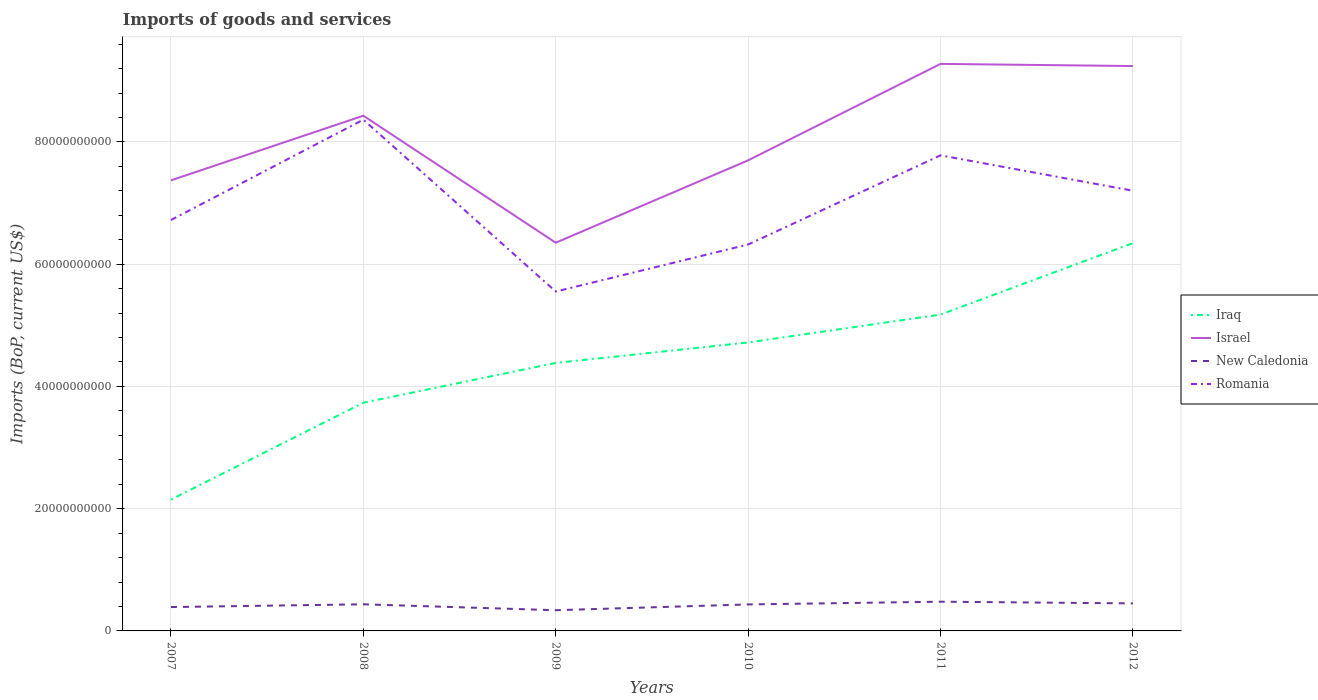Across all years, what is the maximum amount spent on imports in New Caledonia?
Your response must be concise. 3.39e+09. In which year was the amount spent on imports in Israel maximum?
Ensure brevity in your answer.  2009. What is the total amount spent on imports in Israel in the graph?
Give a very brief answer. -2.93e+1. What is the difference between the highest and the second highest amount spent on imports in Iraq?
Ensure brevity in your answer.  4.20e+1. Is the amount spent on imports in New Caledonia strictly greater than the amount spent on imports in Romania over the years?
Keep it short and to the point. Yes. How many lines are there?
Give a very brief answer. 4. How many years are there in the graph?
Offer a very short reply. 6. What is the difference between two consecutive major ticks on the Y-axis?
Provide a short and direct response. 2.00e+1. Does the graph contain any zero values?
Offer a very short reply. No. Does the graph contain grids?
Make the answer very short. Yes. How are the legend labels stacked?
Provide a short and direct response. Vertical. What is the title of the graph?
Provide a short and direct response. Imports of goods and services. Does "Libya" appear as one of the legend labels in the graph?
Keep it short and to the point. No. What is the label or title of the Y-axis?
Make the answer very short. Imports (BoP, current US$). What is the Imports (BoP, current US$) of Iraq in 2007?
Your answer should be very brief. 2.15e+1. What is the Imports (BoP, current US$) of Israel in 2007?
Your response must be concise. 7.37e+1. What is the Imports (BoP, current US$) in New Caledonia in 2007?
Provide a succinct answer. 3.90e+09. What is the Imports (BoP, current US$) of Romania in 2007?
Ensure brevity in your answer.  6.72e+1. What is the Imports (BoP, current US$) in Iraq in 2008?
Your answer should be very brief. 3.73e+1. What is the Imports (BoP, current US$) in Israel in 2008?
Offer a very short reply. 8.43e+1. What is the Imports (BoP, current US$) of New Caledonia in 2008?
Your response must be concise. 4.35e+09. What is the Imports (BoP, current US$) of Romania in 2008?
Your response must be concise. 8.36e+1. What is the Imports (BoP, current US$) in Iraq in 2009?
Make the answer very short. 4.38e+1. What is the Imports (BoP, current US$) of Israel in 2009?
Your answer should be very brief. 6.35e+1. What is the Imports (BoP, current US$) of New Caledonia in 2009?
Give a very brief answer. 3.39e+09. What is the Imports (BoP, current US$) in Romania in 2009?
Give a very brief answer. 5.55e+1. What is the Imports (BoP, current US$) in Iraq in 2010?
Your answer should be very brief. 4.72e+1. What is the Imports (BoP, current US$) of Israel in 2010?
Give a very brief answer. 7.70e+1. What is the Imports (BoP, current US$) in New Caledonia in 2010?
Provide a short and direct response. 4.33e+09. What is the Imports (BoP, current US$) in Romania in 2010?
Your answer should be compact. 6.32e+1. What is the Imports (BoP, current US$) of Iraq in 2011?
Your answer should be very brief. 5.18e+1. What is the Imports (BoP, current US$) in Israel in 2011?
Make the answer very short. 9.28e+1. What is the Imports (BoP, current US$) of New Caledonia in 2011?
Give a very brief answer. 4.78e+09. What is the Imports (BoP, current US$) in Romania in 2011?
Provide a short and direct response. 7.78e+1. What is the Imports (BoP, current US$) of Iraq in 2012?
Offer a terse response. 6.34e+1. What is the Imports (BoP, current US$) of Israel in 2012?
Give a very brief answer. 9.24e+1. What is the Imports (BoP, current US$) in New Caledonia in 2012?
Offer a terse response. 4.50e+09. What is the Imports (BoP, current US$) of Romania in 2012?
Ensure brevity in your answer.  7.20e+1. Across all years, what is the maximum Imports (BoP, current US$) in Iraq?
Offer a terse response. 6.34e+1. Across all years, what is the maximum Imports (BoP, current US$) of Israel?
Provide a succinct answer. 9.28e+1. Across all years, what is the maximum Imports (BoP, current US$) of New Caledonia?
Your response must be concise. 4.78e+09. Across all years, what is the maximum Imports (BoP, current US$) in Romania?
Ensure brevity in your answer.  8.36e+1. Across all years, what is the minimum Imports (BoP, current US$) in Iraq?
Provide a short and direct response. 2.15e+1. Across all years, what is the minimum Imports (BoP, current US$) in Israel?
Make the answer very short. 6.35e+1. Across all years, what is the minimum Imports (BoP, current US$) of New Caledonia?
Offer a terse response. 3.39e+09. Across all years, what is the minimum Imports (BoP, current US$) in Romania?
Offer a terse response. 5.55e+1. What is the total Imports (BoP, current US$) in Iraq in the graph?
Ensure brevity in your answer.  2.65e+11. What is the total Imports (BoP, current US$) of Israel in the graph?
Provide a succinct answer. 4.84e+11. What is the total Imports (BoP, current US$) in New Caledonia in the graph?
Give a very brief answer. 2.53e+1. What is the total Imports (BoP, current US$) in Romania in the graph?
Provide a short and direct response. 4.19e+11. What is the difference between the Imports (BoP, current US$) of Iraq in 2007 and that in 2008?
Give a very brief answer. -1.58e+1. What is the difference between the Imports (BoP, current US$) of Israel in 2007 and that in 2008?
Ensure brevity in your answer.  -1.06e+1. What is the difference between the Imports (BoP, current US$) in New Caledonia in 2007 and that in 2008?
Offer a very short reply. -4.51e+08. What is the difference between the Imports (BoP, current US$) of Romania in 2007 and that in 2008?
Provide a short and direct response. -1.64e+1. What is the difference between the Imports (BoP, current US$) of Iraq in 2007 and that in 2009?
Ensure brevity in your answer.  -2.24e+1. What is the difference between the Imports (BoP, current US$) of Israel in 2007 and that in 2009?
Give a very brief answer. 1.02e+1. What is the difference between the Imports (BoP, current US$) in New Caledonia in 2007 and that in 2009?
Provide a succinct answer. 5.16e+08. What is the difference between the Imports (BoP, current US$) in Romania in 2007 and that in 2009?
Offer a very short reply. 1.17e+1. What is the difference between the Imports (BoP, current US$) of Iraq in 2007 and that in 2010?
Make the answer very short. -2.57e+1. What is the difference between the Imports (BoP, current US$) of Israel in 2007 and that in 2010?
Give a very brief answer. -3.27e+09. What is the difference between the Imports (BoP, current US$) in New Caledonia in 2007 and that in 2010?
Make the answer very short. -4.29e+08. What is the difference between the Imports (BoP, current US$) of Romania in 2007 and that in 2010?
Ensure brevity in your answer.  4.01e+09. What is the difference between the Imports (BoP, current US$) in Iraq in 2007 and that in 2011?
Make the answer very short. -3.03e+1. What is the difference between the Imports (BoP, current US$) of Israel in 2007 and that in 2011?
Offer a terse response. -1.91e+1. What is the difference between the Imports (BoP, current US$) of New Caledonia in 2007 and that in 2011?
Give a very brief answer. -8.78e+08. What is the difference between the Imports (BoP, current US$) of Romania in 2007 and that in 2011?
Your answer should be very brief. -1.06e+1. What is the difference between the Imports (BoP, current US$) in Iraq in 2007 and that in 2012?
Your response must be concise. -4.20e+1. What is the difference between the Imports (BoP, current US$) in Israel in 2007 and that in 2012?
Offer a terse response. -1.87e+1. What is the difference between the Imports (BoP, current US$) of New Caledonia in 2007 and that in 2012?
Ensure brevity in your answer.  -6.01e+08. What is the difference between the Imports (BoP, current US$) in Romania in 2007 and that in 2012?
Your answer should be compact. -4.79e+09. What is the difference between the Imports (BoP, current US$) of Iraq in 2008 and that in 2009?
Your answer should be very brief. -6.51e+09. What is the difference between the Imports (BoP, current US$) of Israel in 2008 and that in 2009?
Offer a very short reply. 2.08e+1. What is the difference between the Imports (BoP, current US$) of New Caledonia in 2008 and that in 2009?
Offer a very short reply. 9.67e+08. What is the difference between the Imports (BoP, current US$) in Romania in 2008 and that in 2009?
Provide a short and direct response. 2.81e+1. What is the difference between the Imports (BoP, current US$) in Iraq in 2008 and that in 2010?
Your answer should be very brief. -9.86e+09. What is the difference between the Imports (BoP, current US$) of Israel in 2008 and that in 2010?
Ensure brevity in your answer.  7.30e+09. What is the difference between the Imports (BoP, current US$) of New Caledonia in 2008 and that in 2010?
Offer a terse response. 2.13e+07. What is the difference between the Imports (BoP, current US$) of Romania in 2008 and that in 2010?
Offer a very short reply. 2.04e+1. What is the difference between the Imports (BoP, current US$) of Iraq in 2008 and that in 2011?
Offer a very short reply. -1.44e+1. What is the difference between the Imports (BoP, current US$) in Israel in 2008 and that in 2011?
Keep it short and to the point. -8.48e+09. What is the difference between the Imports (BoP, current US$) in New Caledonia in 2008 and that in 2011?
Make the answer very short. -4.27e+08. What is the difference between the Imports (BoP, current US$) of Romania in 2008 and that in 2011?
Ensure brevity in your answer.  5.84e+09. What is the difference between the Imports (BoP, current US$) of Iraq in 2008 and that in 2012?
Make the answer very short. -2.61e+1. What is the difference between the Imports (BoP, current US$) in Israel in 2008 and that in 2012?
Your answer should be very brief. -8.13e+09. What is the difference between the Imports (BoP, current US$) in New Caledonia in 2008 and that in 2012?
Keep it short and to the point. -1.50e+08. What is the difference between the Imports (BoP, current US$) of Romania in 2008 and that in 2012?
Offer a terse response. 1.16e+1. What is the difference between the Imports (BoP, current US$) in Iraq in 2009 and that in 2010?
Give a very brief answer. -3.34e+09. What is the difference between the Imports (BoP, current US$) of Israel in 2009 and that in 2010?
Provide a short and direct response. -1.35e+1. What is the difference between the Imports (BoP, current US$) of New Caledonia in 2009 and that in 2010?
Your response must be concise. -9.46e+08. What is the difference between the Imports (BoP, current US$) in Romania in 2009 and that in 2010?
Provide a short and direct response. -7.69e+09. What is the difference between the Imports (BoP, current US$) of Iraq in 2009 and that in 2011?
Your answer should be very brief. -7.91e+09. What is the difference between the Imports (BoP, current US$) of Israel in 2009 and that in 2011?
Your response must be concise. -2.93e+1. What is the difference between the Imports (BoP, current US$) in New Caledonia in 2009 and that in 2011?
Keep it short and to the point. -1.39e+09. What is the difference between the Imports (BoP, current US$) of Romania in 2009 and that in 2011?
Your answer should be very brief. -2.23e+1. What is the difference between the Imports (BoP, current US$) of Iraq in 2009 and that in 2012?
Your answer should be compact. -1.96e+1. What is the difference between the Imports (BoP, current US$) in Israel in 2009 and that in 2012?
Your answer should be very brief. -2.89e+1. What is the difference between the Imports (BoP, current US$) of New Caledonia in 2009 and that in 2012?
Keep it short and to the point. -1.12e+09. What is the difference between the Imports (BoP, current US$) of Romania in 2009 and that in 2012?
Keep it short and to the point. -1.65e+1. What is the difference between the Imports (BoP, current US$) in Iraq in 2010 and that in 2011?
Your answer should be compact. -4.57e+09. What is the difference between the Imports (BoP, current US$) in Israel in 2010 and that in 2011?
Offer a very short reply. -1.58e+1. What is the difference between the Imports (BoP, current US$) in New Caledonia in 2010 and that in 2011?
Provide a short and direct response. -4.48e+08. What is the difference between the Imports (BoP, current US$) in Romania in 2010 and that in 2011?
Your answer should be very brief. -1.46e+1. What is the difference between the Imports (BoP, current US$) of Iraq in 2010 and that in 2012?
Your response must be concise. -1.63e+1. What is the difference between the Imports (BoP, current US$) in Israel in 2010 and that in 2012?
Provide a short and direct response. -1.54e+1. What is the difference between the Imports (BoP, current US$) of New Caledonia in 2010 and that in 2012?
Your answer should be very brief. -1.71e+08. What is the difference between the Imports (BoP, current US$) of Romania in 2010 and that in 2012?
Provide a succinct answer. -8.80e+09. What is the difference between the Imports (BoP, current US$) in Iraq in 2011 and that in 2012?
Keep it short and to the point. -1.17e+1. What is the difference between the Imports (BoP, current US$) of Israel in 2011 and that in 2012?
Your response must be concise. 3.53e+08. What is the difference between the Imports (BoP, current US$) in New Caledonia in 2011 and that in 2012?
Keep it short and to the point. 2.77e+08. What is the difference between the Imports (BoP, current US$) of Romania in 2011 and that in 2012?
Give a very brief answer. 5.79e+09. What is the difference between the Imports (BoP, current US$) in Iraq in 2007 and the Imports (BoP, current US$) in Israel in 2008?
Provide a short and direct response. -6.28e+1. What is the difference between the Imports (BoP, current US$) of Iraq in 2007 and the Imports (BoP, current US$) of New Caledonia in 2008?
Offer a very short reply. 1.71e+1. What is the difference between the Imports (BoP, current US$) of Iraq in 2007 and the Imports (BoP, current US$) of Romania in 2008?
Offer a terse response. -6.22e+1. What is the difference between the Imports (BoP, current US$) of Israel in 2007 and the Imports (BoP, current US$) of New Caledonia in 2008?
Your answer should be compact. 6.94e+1. What is the difference between the Imports (BoP, current US$) of Israel in 2007 and the Imports (BoP, current US$) of Romania in 2008?
Make the answer very short. -9.93e+09. What is the difference between the Imports (BoP, current US$) in New Caledonia in 2007 and the Imports (BoP, current US$) in Romania in 2008?
Ensure brevity in your answer.  -7.97e+1. What is the difference between the Imports (BoP, current US$) in Iraq in 2007 and the Imports (BoP, current US$) in Israel in 2009?
Make the answer very short. -4.20e+1. What is the difference between the Imports (BoP, current US$) in Iraq in 2007 and the Imports (BoP, current US$) in New Caledonia in 2009?
Your response must be concise. 1.81e+1. What is the difference between the Imports (BoP, current US$) of Iraq in 2007 and the Imports (BoP, current US$) of Romania in 2009?
Your answer should be very brief. -3.40e+1. What is the difference between the Imports (BoP, current US$) in Israel in 2007 and the Imports (BoP, current US$) in New Caledonia in 2009?
Provide a succinct answer. 7.03e+1. What is the difference between the Imports (BoP, current US$) of Israel in 2007 and the Imports (BoP, current US$) of Romania in 2009?
Your answer should be compact. 1.82e+1. What is the difference between the Imports (BoP, current US$) in New Caledonia in 2007 and the Imports (BoP, current US$) in Romania in 2009?
Your answer should be compact. -5.16e+1. What is the difference between the Imports (BoP, current US$) in Iraq in 2007 and the Imports (BoP, current US$) in Israel in 2010?
Provide a succinct answer. -5.55e+1. What is the difference between the Imports (BoP, current US$) in Iraq in 2007 and the Imports (BoP, current US$) in New Caledonia in 2010?
Your response must be concise. 1.72e+1. What is the difference between the Imports (BoP, current US$) in Iraq in 2007 and the Imports (BoP, current US$) in Romania in 2010?
Provide a succinct answer. -4.17e+1. What is the difference between the Imports (BoP, current US$) in Israel in 2007 and the Imports (BoP, current US$) in New Caledonia in 2010?
Your answer should be very brief. 6.94e+1. What is the difference between the Imports (BoP, current US$) in Israel in 2007 and the Imports (BoP, current US$) in Romania in 2010?
Keep it short and to the point. 1.05e+1. What is the difference between the Imports (BoP, current US$) in New Caledonia in 2007 and the Imports (BoP, current US$) in Romania in 2010?
Ensure brevity in your answer.  -5.93e+1. What is the difference between the Imports (BoP, current US$) in Iraq in 2007 and the Imports (BoP, current US$) in Israel in 2011?
Give a very brief answer. -7.13e+1. What is the difference between the Imports (BoP, current US$) in Iraq in 2007 and the Imports (BoP, current US$) in New Caledonia in 2011?
Keep it short and to the point. 1.67e+1. What is the difference between the Imports (BoP, current US$) of Iraq in 2007 and the Imports (BoP, current US$) of Romania in 2011?
Provide a short and direct response. -5.63e+1. What is the difference between the Imports (BoP, current US$) of Israel in 2007 and the Imports (BoP, current US$) of New Caledonia in 2011?
Your response must be concise. 6.89e+1. What is the difference between the Imports (BoP, current US$) in Israel in 2007 and the Imports (BoP, current US$) in Romania in 2011?
Provide a succinct answer. -4.09e+09. What is the difference between the Imports (BoP, current US$) in New Caledonia in 2007 and the Imports (BoP, current US$) in Romania in 2011?
Offer a very short reply. -7.39e+1. What is the difference between the Imports (BoP, current US$) in Iraq in 2007 and the Imports (BoP, current US$) in Israel in 2012?
Provide a succinct answer. -7.09e+1. What is the difference between the Imports (BoP, current US$) of Iraq in 2007 and the Imports (BoP, current US$) of New Caledonia in 2012?
Offer a terse response. 1.70e+1. What is the difference between the Imports (BoP, current US$) in Iraq in 2007 and the Imports (BoP, current US$) in Romania in 2012?
Provide a succinct answer. -5.05e+1. What is the difference between the Imports (BoP, current US$) of Israel in 2007 and the Imports (BoP, current US$) of New Caledonia in 2012?
Give a very brief answer. 6.92e+1. What is the difference between the Imports (BoP, current US$) of Israel in 2007 and the Imports (BoP, current US$) of Romania in 2012?
Offer a very short reply. 1.70e+09. What is the difference between the Imports (BoP, current US$) in New Caledonia in 2007 and the Imports (BoP, current US$) in Romania in 2012?
Provide a short and direct response. -6.81e+1. What is the difference between the Imports (BoP, current US$) in Iraq in 2008 and the Imports (BoP, current US$) in Israel in 2009?
Make the answer very short. -2.62e+1. What is the difference between the Imports (BoP, current US$) of Iraq in 2008 and the Imports (BoP, current US$) of New Caledonia in 2009?
Your answer should be very brief. 3.39e+1. What is the difference between the Imports (BoP, current US$) of Iraq in 2008 and the Imports (BoP, current US$) of Romania in 2009?
Provide a short and direct response. -1.82e+1. What is the difference between the Imports (BoP, current US$) of Israel in 2008 and the Imports (BoP, current US$) of New Caledonia in 2009?
Your answer should be compact. 8.09e+1. What is the difference between the Imports (BoP, current US$) in Israel in 2008 and the Imports (BoP, current US$) in Romania in 2009?
Keep it short and to the point. 2.88e+1. What is the difference between the Imports (BoP, current US$) of New Caledonia in 2008 and the Imports (BoP, current US$) of Romania in 2009?
Your answer should be compact. -5.12e+1. What is the difference between the Imports (BoP, current US$) in Iraq in 2008 and the Imports (BoP, current US$) in Israel in 2010?
Give a very brief answer. -3.97e+1. What is the difference between the Imports (BoP, current US$) of Iraq in 2008 and the Imports (BoP, current US$) of New Caledonia in 2010?
Keep it short and to the point. 3.30e+1. What is the difference between the Imports (BoP, current US$) of Iraq in 2008 and the Imports (BoP, current US$) of Romania in 2010?
Ensure brevity in your answer.  -2.59e+1. What is the difference between the Imports (BoP, current US$) of Israel in 2008 and the Imports (BoP, current US$) of New Caledonia in 2010?
Provide a succinct answer. 8.00e+1. What is the difference between the Imports (BoP, current US$) in Israel in 2008 and the Imports (BoP, current US$) in Romania in 2010?
Your answer should be compact. 2.11e+1. What is the difference between the Imports (BoP, current US$) in New Caledonia in 2008 and the Imports (BoP, current US$) in Romania in 2010?
Provide a short and direct response. -5.89e+1. What is the difference between the Imports (BoP, current US$) in Iraq in 2008 and the Imports (BoP, current US$) in Israel in 2011?
Provide a short and direct response. -5.54e+1. What is the difference between the Imports (BoP, current US$) of Iraq in 2008 and the Imports (BoP, current US$) of New Caledonia in 2011?
Your answer should be very brief. 3.26e+1. What is the difference between the Imports (BoP, current US$) in Iraq in 2008 and the Imports (BoP, current US$) in Romania in 2011?
Provide a short and direct response. -4.05e+1. What is the difference between the Imports (BoP, current US$) of Israel in 2008 and the Imports (BoP, current US$) of New Caledonia in 2011?
Provide a succinct answer. 7.95e+1. What is the difference between the Imports (BoP, current US$) of Israel in 2008 and the Imports (BoP, current US$) of Romania in 2011?
Offer a very short reply. 6.48e+09. What is the difference between the Imports (BoP, current US$) in New Caledonia in 2008 and the Imports (BoP, current US$) in Romania in 2011?
Keep it short and to the point. -7.35e+1. What is the difference between the Imports (BoP, current US$) of Iraq in 2008 and the Imports (BoP, current US$) of Israel in 2012?
Your answer should be very brief. -5.51e+1. What is the difference between the Imports (BoP, current US$) of Iraq in 2008 and the Imports (BoP, current US$) of New Caledonia in 2012?
Your response must be concise. 3.28e+1. What is the difference between the Imports (BoP, current US$) of Iraq in 2008 and the Imports (BoP, current US$) of Romania in 2012?
Offer a terse response. -3.47e+1. What is the difference between the Imports (BoP, current US$) of Israel in 2008 and the Imports (BoP, current US$) of New Caledonia in 2012?
Keep it short and to the point. 7.98e+1. What is the difference between the Imports (BoP, current US$) in Israel in 2008 and the Imports (BoP, current US$) in Romania in 2012?
Offer a terse response. 1.23e+1. What is the difference between the Imports (BoP, current US$) in New Caledonia in 2008 and the Imports (BoP, current US$) in Romania in 2012?
Provide a short and direct response. -6.77e+1. What is the difference between the Imports (BoP, current US$) in Iraq in 2009 and the Imports (BoP, current US$) in Israel in 2010?
Provide a succinct answer. -3.31e+1. What is the difference between the Imports (BoP, current US$) in Iraq in 2009 and the Imports (BoP, current US$) in New Caledonia in 2010?
Offer a very short reply. 3.95e+1. What is the difference between the Imports (BoP, current US$) of Iraq in 2009 and the Imports (BoP, current US$) of Romania in 2010?
Provide a short and direct response. -1.94e+1. What is the difference between the Imports (BoP, current US$) of Israel in 2009 and the Imports (BoP, current US$) of New Caledonia in 2010?
Provide a short and direct response. 5.92e+1. What is the difference between the Imports (BoP, current US$) of Israel in 2009 and the Imports (BoP, current US$) of Romania in 2010?
Provide a succinct answer. 2.94e+08. What is the difference between the Imports (BoP, current US$) in New Caledonia in 2009 and the Imports (BoP, current US$) in Romania in 2010?
Your answer should be very brief. -5.98e+1. What is the difference between the Imports (BoP, current US$) of Iraq in 2009 and the Imports (BoP, current US$) of Israel in 2011?
Offer a terse response. -4.89e+1. What is the difference between the Imports (BoP, current US$) in Iraq in 2009 and the Imports (BoP, current US$) in New Caledonia in 2011?
Your answer should be very brief. 3.91e+1. What is the difference between the Imports (BoP, current US$) in Iraq in 2009 and the Imports (BoP, current US$) in Romania in 2011?
Your answer should be compact. -3.40e+1. What is the difference between the Imports (BoP, current US$) of Israel in 2009 and the Imports (BoP, current US$) of New Caledonia in 2011?
Provide a short and direct response. 5.87e+1. What is the difference between the Imports (BoP, current US$) of Israel in 2009 and the Imports (BoP, current US$) of Romania in 2011?
Keep it short and to the point. -1.43e+1. What is the difference between the Imports (BoP, current US$) of New Caledonia in 2009 and the Imports (BoP, current US$) of Romania in 2011?
Ensure brevity in your answer.  -7.44e+1. What is the difference between the Imports (BoP, current US$) in Iraq in 2009 and the Imports (BoP, current US$) in Israel in 2012?
Give a very brief answer. -4.86e+1. What is the difference between the Imports (BoP, current US$) in Iraq in 2009 and the Imports (BoP, current US$) in New Caledonia in 2012?
Ensure brevity in your answer.  3.93e+1. What is the difference between the Imports (BoP, current US$) in Iraq in 2009 and the Imports (BoP, current US$) in Romania in 2012?
Your answer should be very brief. -2.82e+1. What is the difference between the Imports (BoP, current US$) of Israel in 2009 and the Imports (BoP, current US$) of New Caledonia in 2012?
Provide a short and direct response. 5.90e+1. What is the difference between the Imports (BoP, current US$) in Israel in 2009 and the Imports (BoP, current US$) in Romania in 2012?
Offer a very short reply. -8.50e+09. What is the difference between the Imports (BoP, current US$) in New Caledonia in 2009 and the Imports (BoP, current US$) in Romania in 2012?
Your answer should be compact. -6.86e+1. What is the difference between the Imports (BoP, current US$) of Iraq in 2010 and the Imports (BoP, current US$) of Israel in 2011?
Provide a succinct answer. -4.56e+1. What is the difference between the Imports (BoP, current US$) of Iraq in 2010 and the Imports (BoP, current US$) of New Caledonia in 2011?
Ensure brevity in your answer.  4.24e+1. What is the difference between the Imports (BoP, current US$) of Iraq in 2010 and the Imports (BoP, current US$) of Romania in 2011?
Provide a succinct answer. -3.06e+1. What is the difference between the Imports (BoP, current US$) of Israel in 2010 and the Imports (BoP, current US$) of New Caledonia in 2011?
Your answer should be compact. 7.22e+1. What is the difference between the Imports (BoP, current US$) in Israel in 2010 and the Imports (BoP, current US$) in Romania in 2011?
Ensure brevity in your answer.  -8.18e+08. What is the difference between the Imports (BoP, current US$) of New Caledonia in 2010 and the Imports (BoP, current US$) of Romania in 2011?
Your response must be concise. -7.35e+1. What is the difference between the Imports (BoP, current US$) of Iraq in 2010 and the Imports (BoP, current US$) of Israel in 2012?
Ensure brevity in your answer.  -4.52e+1. What is the difference between the Imports (BoP, current US$) of Iraq in 2010 and the Imports (BoP, current US$) of New Caledonia in 2012?
Provide a succinct answer. 4.27e+1. What is the difference between the Imports (BoP, current US$) in Iraq in 2010 and the Imports (BoP, current US$) in Romania in 2012?
Ensure brevity in your answer.  -2.48e+1. What is the difference between the Imports (BoP, current US$) in Israel in 2010 and the Imports (BoP, current US$) in New Caledonia in 2012?
Ensure brevity in your answer.  7.25e+1. What is the difference between the Imports (BoP, current US$) of Israel in 2010 and the Imports (BoP, current US$) of Romania in 2012?
Offer a terse response. 4.97e+09. What is the difference between the Imports (BoP, current US$) of New Caledonia in 2010 and the Imports (BoP, current US$) of Romania in 2012?
Your answer should be very brief. -6.77e+1. What is the difference between the Imports (BoP, current US$) of Iraq in 2011 and the Imports (BoP, current US$) of Israel in 2012?
Make the answer very short. -4.07e+1. What is the difference between the Imports (BoP, current US$) of Iraq in 2011 and the Imports (BoP, current US$) of New Caledonia in 2012?
Give a very brief answer. 4.73e+1. What is the difference between the Imports (BoP, current US$) of Iraq in 2011 and the Imports (BoP, current US$) of Romania in 2012?
Keep it short and to the point. -2.03e+1. What is the difference between the Imports (BoP, current US$) of Israel in 2011 and the Imports (BoP, current US$) of New Caledonia in 2012?
Provide a short and direct response. 8.83e+1. What is the difference between the Imports (BoP, current US$) in Israel in 2011 and the Imports (BoP, current US$) in Romania in 2012?
Your response must be concise. 2.08e+1. What is the difference between the Imports (BoP, current US$) in New Caledonia in 2011 and the Imports (BoP, current US$) in Romania in 2012?
Provide a short and direct response. -6.72e+1. What is the average Imports (BoP, current US$) in Iraq per year?
Provide a succinct answer. 4.42e+1. What is the average Imports (BoP, current US$) in Israel per year?
Your response must be concise. 8.06e+1. What is the average Imports (BoP, current US$) of New Caledonia per year?
Offer a very short reply. 4.21e+09. What is the average Imports (BoP, current US$) of Romania per year?
Make the answer very short. 6.99e+1. In the year 2007, what is the difference between the Imports (BoP, current US$) in Iraq and Imports (BoP, current US$) in Israel?
Your answer should be very brief. -5.22e+1. In the year 2007, what is the difference between the Imports (BoP, current US$) in Iraq and Imports (BoP, current US$) in New Caledonia?
Your response must be concise. 1.76e+1. In the year 2007, what is the difference between the Imports (BoP, current US$) in Iraq and Imports (BoP, current US$) in Romania?
Give a very brief answer. -4.57e+1. In the year 2007, what is the difference between the Imports (BoP, current US$) of Israel and Imports (BoP, current US$) of New Caledonia?
Your response must be concise. 6.98e+1. In the year 2007, what is the difference between the Imports (BoP, current US$) in Israel and Imports (BoP, current US$) in Romania?
Provide a short and direct response. 6.49e+09. In the year 2007, what is the difference between the Imports (BoP, current US$) in New Caledonia and Imports (BoP, current US$) in Romania?
Provide a short and direct response. -6.33e+1. In the year 2008, what is the difference between the Imports (BoP, current US$) in Iraq and Imports (BoP, current US$) in Israel?
Provide a succinct answer. -4.70e+1. In the year 2008, what is the difference between the Imports (BoP, current US$) in Iraq and Imports (BoP, current US$) in New Caledonia?
Provide a short and direct response. 3.30e+1. In the year 2008, what is the difference between the Imports (BoP, current US$) in Iraq and Imports (BoP, current US$) in Romania?
Your answer should be compact. -4.63e+1. In the year 2008, what is the difference between the Imports (BoP, current US$) of Israel and Imports (BoP, current US$) of New Caledonia?
Your response must be concise. 7.99e+1. In the year 2008, what is the difference between the Imports (BoP, current US$) in Israel and Imports (BoP, current US$) in Romania?
Offer a terse response. 6.44e+08. In the year 2008, what is the difference between the Imports (BoP, current US$) of New Caledonia and Imports (BoP, current US$) of Romania?
Make the answer very short. -7.93e+1. In the year 2009, what is the difference between the Imports (BoP, current US$) of Iraq and Imports (BoP, current US$) of Israel?
Provide a succinct answer. -1.97e+1. In the year 2009, what is the difference between the Imports (BoP, current US$) of Iraq and Imports (BoP, current US$) of New Caledonia?
Offer a very short reply. 4.05e+1. In the year 2009, what is the difference between the Imports (BoP, current US$) of Iraq and Imports (BoP, current US$) of Romania?
Your answer should be compact. -1.17e+1. In the year 2009, what is the difference between the Imports (BoP, current US$) of Israel and Imports (BoP, current US$) of New Caledonia?
Keep it short and to the point. 6.01e+1. In the year 2009, what is the difference between the Imports (BoP, current US$) of Israel and Imports (BoP, current US$) of Romania?
Your response must be concise. 7.99e+09. In the year 2009, what is the difference between the Imports (BoP, current US$) in New Caledonia and Imports (BoP, current US$) in Romania?
Your answer should be compact. -5.21e+1. In the year 2010, what is the difference between the Imports (BoP, current US$) of Iraq and Imports (BoP, current US$) of Israel?
Ensure brevity in your answer.  -2.98e+1. In the year 2010, what is the difference between the Imports (BoP, current US$) of Iraq and Imports (BoP, current US$) of New Caledonia?
Give a very brief answer. 4.29e+1. In the year 2010, what is the difference between the Imports (BoP, current US$) of Iraq and Imports (BoP, current US$) of Romania?
Offer a terse response. -1.60e+1. In the year 2010, what is the difference between the Imports (BoP, current US$) of Israel and Imports (BoP, current US$) of New Caledonia?
Give a very brief answer. 7.27e+1. In the year 2010, what is the difference between the Imports (BoP, current US$) in Israel and Imports (BoP, current US$) in Romania?
Ensure brevity in your answer.  1.38e+1. In the year 2010, what is the difference between the Imports (BoP, current US$) of New Caledonia and Imports (BoP, current US$) of Romania?
Your response must be concise. -5.89e+1. In the year 2011, what is the difference between the Imports (BoP, current US$) in Iraq and Imports (BoP, current US$) in Israel?
Give a very brief answer. -4.10e+1. In the year 2011, what is the difference between the Imports (BoP, current US$) of Iraq and Imports (BoP, current US$) of New Caledonia?
Your answer should be very brief. 4.70e+1. In the year 2011, what is the difference between the Imports (BoP, current US$) of Iraq and Imports (BoP, current US$) of Romania?
Provide a succinct answer. -2.60e+1. In the year 2011, what is the difference between the Imports (BoP, current US$) in Israel and Imports (BoP, current US$) in New Caledonia?
Keep it short and to the point. 8.80e+1. In the year 2011, what is the difference between the Imports (BoP, current US$) of Israel and Imports (BoP, current US$) of Romania?
Give a very brief answer. 1.50e+1. In the year 2011, what is the difference between the Imports (BoP, current US$) of New Caledonia and Imports (BoP, current US$) of Romania?
Your answer should be compact. -7.30e+1. In the year 2012, what is the difference between the Imports (BoP, current US$) of Iraq and Imports (BoP, current US$) of Israel?
Ensure brevity in your answer.  -2.90e+1. In the year 2012, what is the difference between the Imports (BoP, current US$) in Iraq and Imports (BoP, current US$) in New Caledonia?
Give a very brief answer. 5.89e+1. In the year 2012, what is the difference between the Imports (BoP, current US$) in Iraq and Imports (BoP, current US$) in Romania?
Offer a very short reply. -8.57e+09. In the year 2012, what is the difference between the Imports (BoP, current US$) in Israel and Imports (BoP, current US$) in New Caledonia?
Provide a succinct answer. 8.79e+1. In the year 2012, what is the difference between the Imports (BoP, current US$) in Israel and Imports (BoP, current US$) in Romania?
Ensure brevity in your answer.  2.04e+1. In the year 2012, what is the difference between the Imports (BoP, current US$) in New Caledonia and Imports (BoP, current US$) in Romania?
Offer a very short reply. -6.75e+1. What is the ratio of the Imports (BoP, current US$) of Iraq in 2007 to that in 2008?
Make the answer very short. 0.58. What is the ratio of the Imports (BoP, current US$) in Israel in 2007 to that in 2008?
Offer a terse response. 0.87. What is the ratio of the Imports (BoP, current US$) in New Caledonia in 2007 to that in 2008?
Your answer should be compact. 0.9. What is the ratio of the Imports (BoP, current US$) in Romania in 2007 to that in 2008?
Keep it short and to the point. 0.8. What is the ratio of the Imports (BoP, current US$) in Iraq in 2007 to that in 2009?
Make the answer very short. 0.49. What is the ratio of the Imports (BoP, current US$) of Israel in 2007 to that in 2009?
Offer a terse response. 1.16. What is the ratio of the Imports (BoP, current US$) of New Caledonia in 2007 to that in 2009?
Your response must be concise. 1.15. What is the ratio of the Imports (BoP, current US$) of Romania in 2007 to that in 2009?
Your response must be concise. 1.21. What is the ratio of the Imports (BoP, current US$) in Iraq in 2007 to that in 2010?
Offer a terse response. 0.46. What is the ratio of the Imports (BoP, current US$) of Israel in 2007 to that in 2010?
Make the answer very short. 0.96. What is the ratio of the Imports (BoP, current US$) of New Caledonia in 2007 to that in 2010?
Offer a terse response. 0.9. What is the ratio of the Imports (BoP, current US$) in Romania in 2007 to that in 2010?
Make the answer very short. 1.06. What is the ratio of the Imports (BoP, current US$) in Iraq in 2007 to that in 2011?
Offer a very short reply. 0.42. What is the ratio of the Imports (BoP, current US$) of Israel in 2007 to that in 2011?
Your answer should be very brief. 0.79. What is the ratio of the Imports (BoP, current US$) of New Caledonia in 2007 to that in 2011?
Keep it short and to the point. 0.82. What is the ratio of the Imports (BoP, current US$) of Romania in 2007 to that in 2011?
Keep it short and to the point. 0.86. What is the ratio of the Imports (BoP, current US$) of Iraq in 2007 to that in 2012?
Make the answer very short. 0.34. What is the ratio of the Imports (BoP, current US$) in Israel in 2007 to that in 2012?
Ensure brevity in your answer.  0.8. What is the ratio of the Imports (BoP, current US$) in New Caledonia in 2007 to that in 2012?
Your answer should be compact. 0.87. What is the ratio of the Imports (BoP, current US$) of Romania in 2007 to that in 2012?
Keep it short and to the point. 0.93. What is the ratio of the Imports (BoP, current US$) in Iraq in 2008 to that in 2009?
Make the answer very short. 0.85. What is the ratio of the Imports (BoP, current US$) of Israel in 2008 to that in 2009?
Your answer should be very brief. 1.33. What is the ratio of the Imports (BoP, current US$) in New Caledonia in 2008 to that in 2009?
Offer a very short reply. 1.29. What is the ratio of the Imports (BoP, current US$) in Romania in 2008 to that in 2009?
Your answer should be compact. 1.51. What is the ratio of the Imports (BoP, current US$) of Iraq in 2008 to that in 2010?
Offer a terse response. 0.79. What is the ratio of the Imports (BoP, current US$) in Israel in 2008 to that in 2010?
Offer a very short reply. 1.09. What is the ratio of the Imports (BoP, current US$) of Romania in 2008 to that in 2010?
Offer a terse response. 1.32. What is the ratio of the Imports (BoP, current US$) in Iraq in 2008 to that in 2011?
Ensure brevity in your answer.  0.72. What is the ratio of the Imports (BoP, current US$) in Israel in 2008 to that in 2011?
Provide a short and direct response. 0.91. What is the ratio of the Imports (BoP, current US$) in New Caledonia in 2008 to that in 2011?
Your response must be concise. 0.91. What is the ratio of the Imports (BoP, current US$) in Romania in 2008 to that in 2011?
Make the answer very short. 1.07. What is the ratio of the Imports (BoP, current US$) of Iraq in 2008 to that in 2012?
Make the answer very short. 0.59. What is the ratio of the Imports (BoP, current US$) in Israel in 2008 to that in 2012?
Make the answer very short. 0.91. What is the ratio of the Imports (BoP, current US$) in New Caledonia in 2008 to that in 2012?
Provide a succinct answer. 0.97. What is the ratio of the Imports (BoP, current US$) in Romania in 2008 to that in 2012?
Provide a short and direct response. 1.16. What is the ratio of the Imports (BoP, current US$) of Iraq in 2009 to that in 2010?
Ensure brevity in your answer.  0.93. What is the ratio of the Imports (BoP, current US$) of Israel in 2009 to that in 2010?
Your response must be concise. 0.82. What is the ratio of the Imports (BoP, current US$) in New Caledonia in 2009 to that in 2010?
Make the answer very short. 0.78. What is the ratio of the Imports (BoP, current US$) of Romania in 2009 to that in 2010?
Make the answer very short. 0.88. What is the ratio of the Imports (BoP, current US$) of Iraq in 2009 to that in 2011?
Offer a terse response. 0.85. What is the ratio of the Imports (BoP, current US$) in Israel in 2009 to that in 2011?
Give a very brief answer. 0.68. What is the ratio of the Imports (BoP, current US$) of New Caledonia in 2009 to that in 2011?
Keep it short and to the point. 0.71. What is the ratio of the Imports (BoP, current US$) in Romania in 2009 to that in 2011?
Provide a succinct answer. 0.71. What is the ratio of the Imports (BoP, current US$) in Iraq in 2009 to that in 2012?
Keep it short and to the point. 0.69. What is the ratio of the Imports (BoP, current US$) in Israel in 2009 to that in 2012?
Offer a terse response. 0.69. What is the ratio of the Imports (BoP, current US$) of New Caledonia in 2009 to that in 2012?
Give a very brief answer. 0.75. What is the ratio of the Imports (BoP, current US$) in Romania in 2009 to that in 2012?
Make the answer very short. 0.77. What is the ratio of the Imports (BoP, current US$) of Iraq in 2010 to that in 2011?
Keep it short and to the point. 0.91. What is the ratio of the Imports (BoP, current US$) in Israel in 2010 to that in 2011?
Keep it short and to the point. 0.83. What is the ratio of the Imports (BoP, current US$) in New Caledonia in 2010 to that in 2011?
Provide a succinct answer. 0.91. What is the ratio of the Imports (BoP, current US$) of Romania in 2010 to that in 2011?
Offer a terse response. 0.81. What is the ratio of the Imports (BoP, current US$) in Iraq in 2010 to that in 2012?
Your answer should be compact. 0.74. What is the ratio of the Imports (BoP, current US$) of Israel in 2010 to that in 2012?
Your answer should be very brief. 0.83. What is the ratio of the Imports (BoP, current US$) in New Caledonia in 2010 to that in 2012?
Offer a very short reply. 0.96. What is the ratio of the Imports (BoP, current US$) in Romania in 2010 to that in 2012?
Your answer should be very brief. 0.88. What is the ratio of the Imports (BoP, current US$) in Iraq in 2011 to that in 2012?
Provide a short and direct response. 0.82. What is the ratio of the Imports (BoP, current US$) of Israel in 2011 to that in 2012?
Your answer should be compact. 1. What is the ratio of the Imports (BoP, current US$) of New Caledonia in 2011 to that in 2012?
Provide a short and direct response. 1.06. What is the ratio of the Imports (BoP, current US$) of Romania in 2011 to that in 2012?
Keep it short and to the point. 1.08. What is the difference between the highest and the second highest Imports (BoP, current US$) in Iraq?
Your answer should be very brief. 1.17e+1. What is the difference between the highest and the second highest Imports (BoP, current US$) of Israel?
Provide a short and direct response. 3.53e+08. What is the difference between the highest and the second highest Imports (BoP, current US$) in New Caledonia?
Provide a short and direct response. 2.77e+08. What is the difference between the highest and the second highest Imports (BoP, current US$) in Romania?
Make the answer very short. 5.84e+09. What is the difference between the highest and the lowest Imports (BoP, current US$) of Iraq?
Ensure brevity in your answer.  4.20e+1. What is the difference between the highest and the lowest Imports (BoP, current US$) of Israel?
Offer a very short reply. 2.93e+1. What is the difference between the highest and the lowest Imports (BoP, current US$) in New Caledonia?
Provide a short and direct response. 1.39e+09. What is the difference between the highest and the lowest Imports (BoP, current US$) of Romania?
Keep it short and to the point. 2.81e+1. 